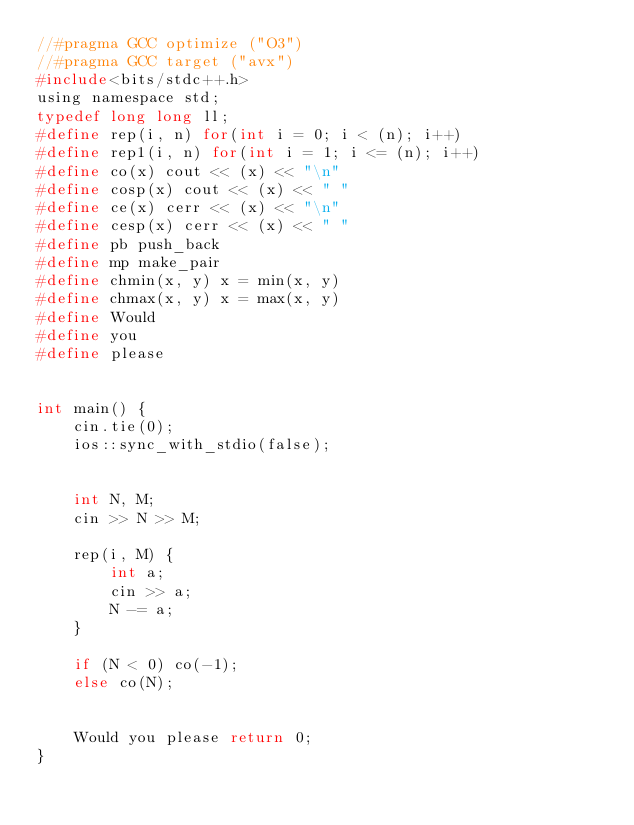Convert code to text. <code><loc_0><loc_0><loc_500><loc_500><_C_>//#pragma GCC optimize ("O3")
//#pragma GCC target ("avx")
#include<bits/stdc++.h>
using namespace std;
typedef long long ll;
#define rep(i, n) for(int i = 0; i < (n); i++)
#define rep1(i, n) for(int i = 1; i <= (n); i++)
#define co(x) cout << (x) << "\n"
#define cosp(x) cout << (x) << " "
#define ce(x) cerr << (x) << "\n"
#define cesp(x) cerr << (x) << " "
#define pb push_back
#define mp make_pair
#define chmin(x, y) x = min(x, y)
#define chmax(x, y) x = max(x, y)
#define Would
#define you
#define please


int main() {
	cin.tie(0);
	ios::sync_with_stdio(false);


	int N, M;
	cin >> N >> M;

	rep(i, M) {
		int a;
		cin >> a;
		N -= a;
	}

	if (N < 0) co(-1);
	else co(N);


	Would you please return 0;
}</code> 